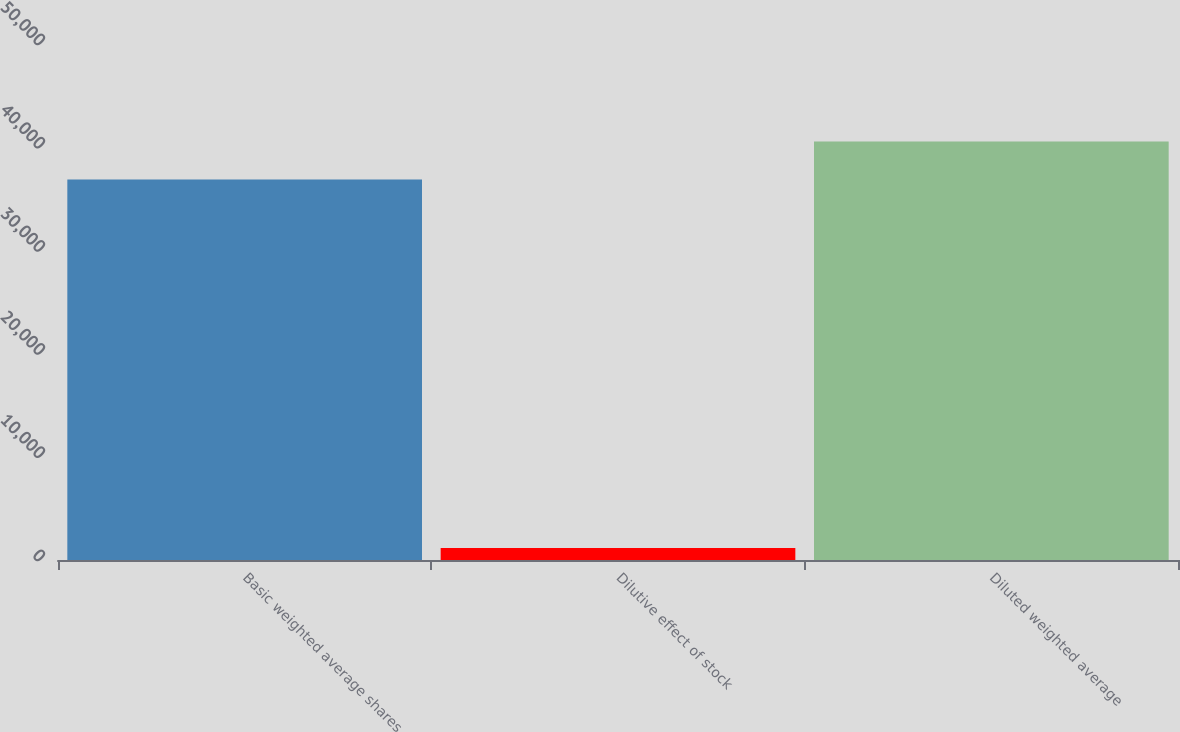<chart> <loc_0><loc_0><loc_500><loc_500><bar_chart><fcel>Basic weighted average shares<fcel>Dilutive effect of stock<fcel>Diluted weighted average<nl><fcel>36864<fcel>1174<fcel>40550.4<nl></chart> 